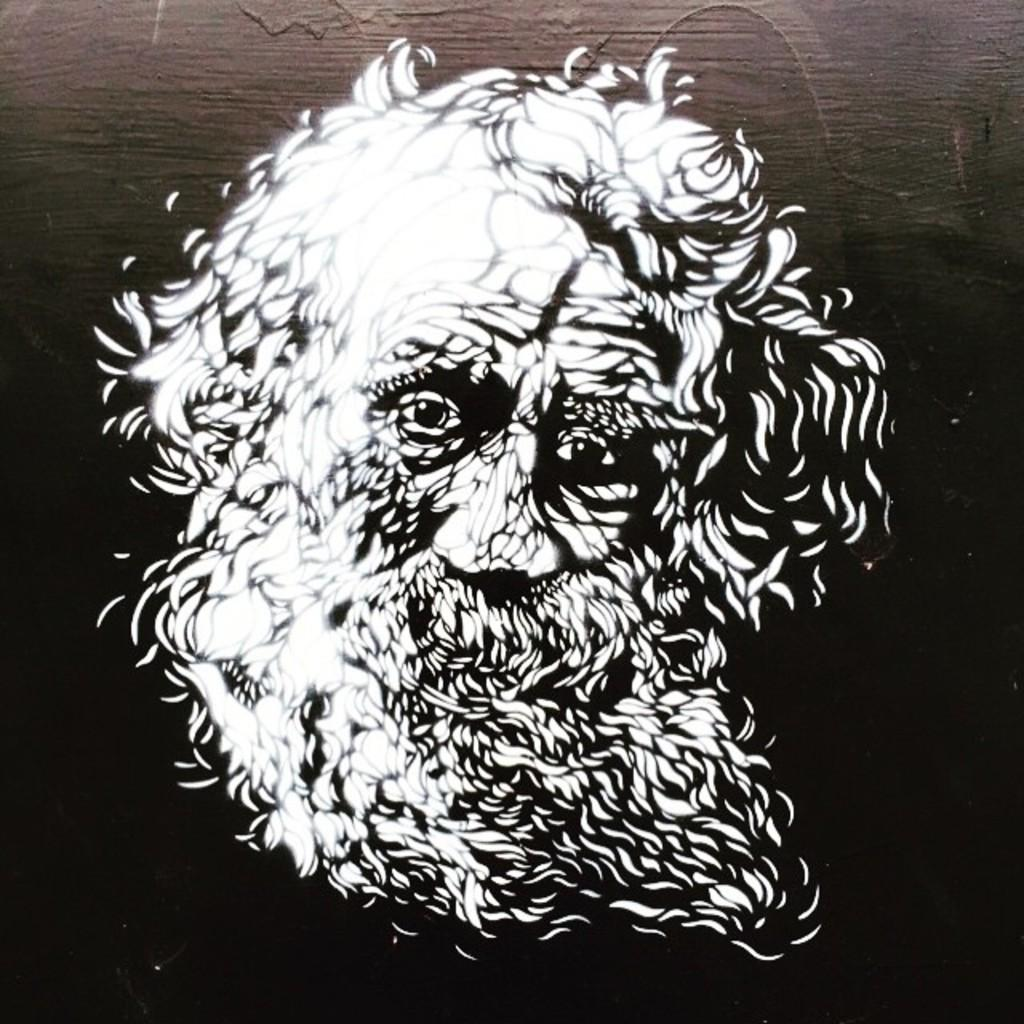What is depicted in the image? The image contains an illustration of a man. What type of illustration is it? The illustration is a sketch. What color is the bottom part of the image? The bottom of the image is black in color. What can be seen in the background of the image? There is a brown wall in the background of the image. What type of voice can be heard coming from the man in the image? There is no voice present in the image, as it is a static illustration of a man. How many women are visible in the image? There are no women present in the image; it only features an illustration of a man. What type of shop is depicted in the image? There is no shop present in the image; it only contains an illustration of a man and a brown wall in the background. 